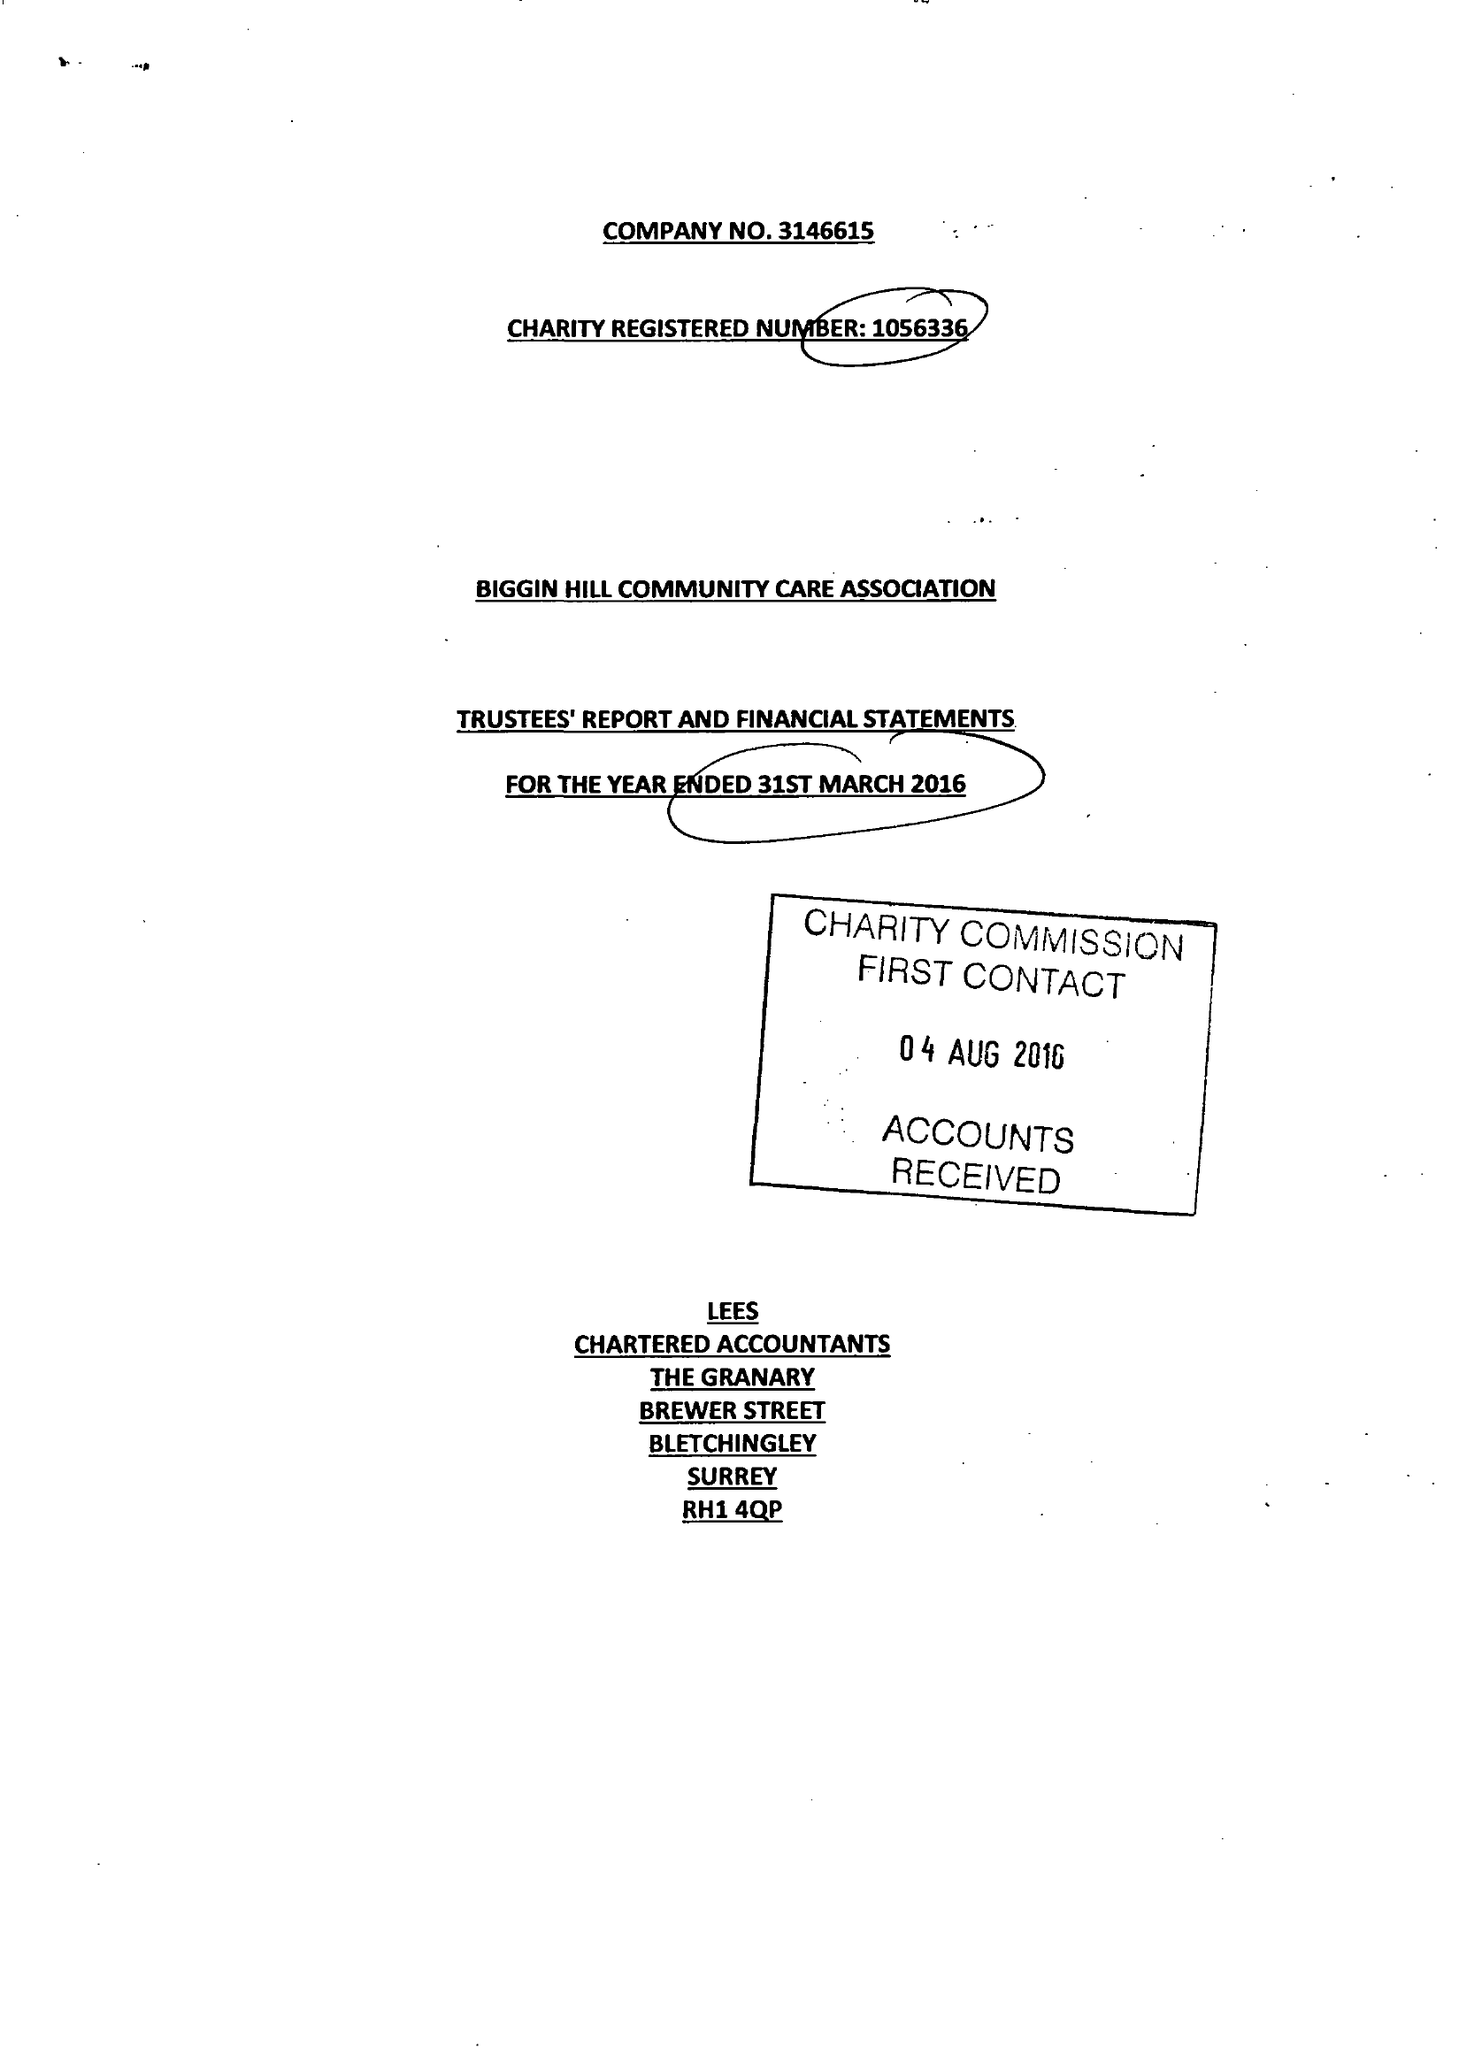What is the value for the address__postcode?
Answer the question using a single word or phrase. TN16 3LB 